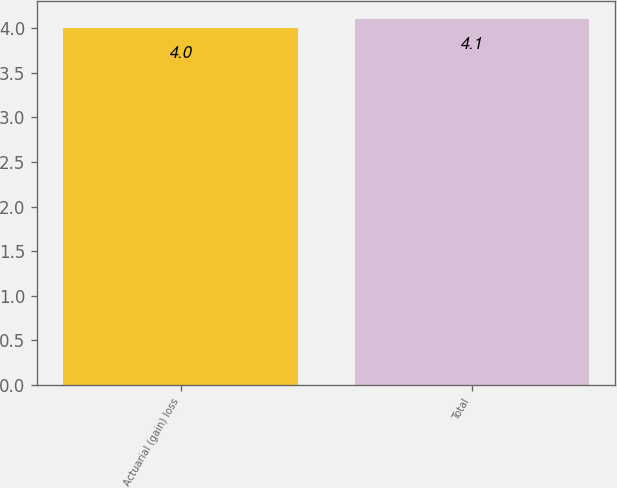Convert chart. <chart><loc_0><loc_0><loc_500><loc_500><bar_chart><fcel>Actuarial (gain) loss<fcel>Total<nl><fcel>4<fcel>4.1<nl></chart> 